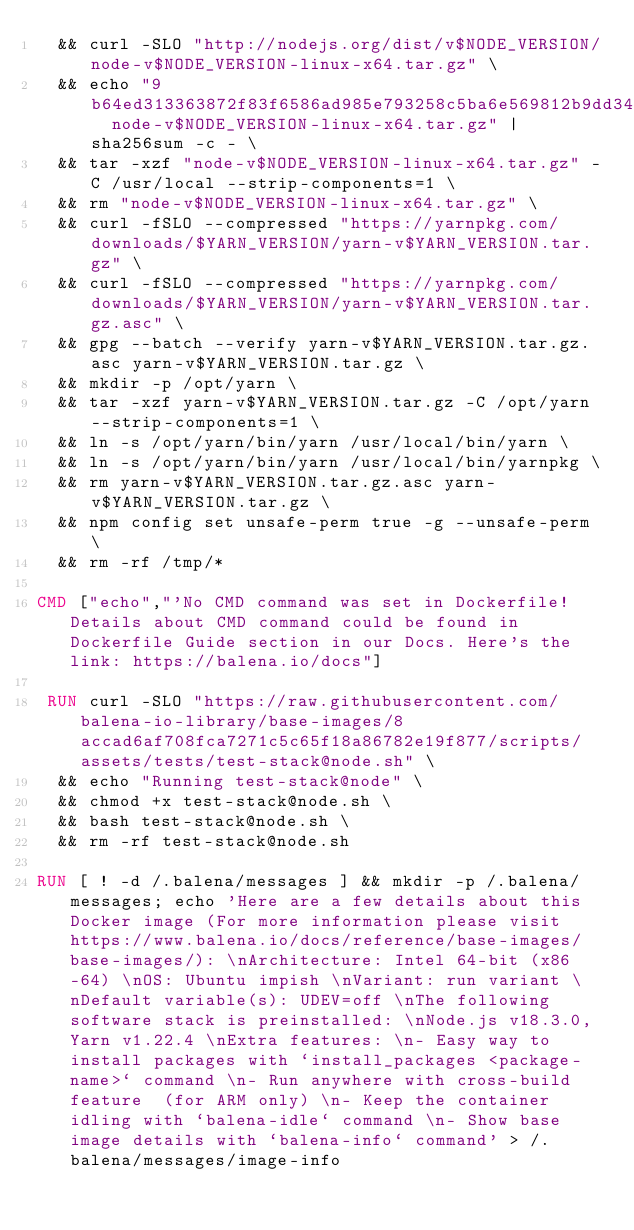<code> <loc_0><loc_0><loc_500><loc_500><_Dockerfile_>	&& curl -SLO "http://nodejs.org/dist/v$NODE_VERSION/node-v$NODE_VERSION-linux-x64.tar.gz" \
	&& echo "9b64ed313363872f83f6586ad985e793258c5ba6e569812b9dd349ec819956cf  node-v$NODE_VERSION-linux-x64.tar.gz" | sha256sum -c - \
	&& tar -xzf "node-v$NODE_VERSION-linux-x64.tar.gz" -C /usr/local --strip-components=1 \
	&& rm "node-v$NODE_VERSION-linux-x64.tar.gz" \
	&& curl -fSLO --compressed "https://yarnpkg.com/downloads/$YARN_VERSION/yarn-v$YARN_VERSION.tar.gz" \
	&& curl -fSLO --compressed "https://yarnpkg.com/downloads/$YARN_VERSION/yarn-v$YARN_VERSION.tar.gz.asc" \
	&& gpg --batch --verify yarn-v$YARN_VERSION.tar.gz.asc yarn-v$YARN_VERSION.tar.gz \
	&& mkdir -p /opt/yarn \
	&& tar -xzf yarn-v$YARN_VERSION.tar.gz -C /opt/yarn --strip-components=1 \
	&& ln -s /opt/yarn/bin/yarn /usr/local/bin/yarn \
	&& ln -s /opt/yarn/bin/yarn /usr/local/bin/yarnpkg \
	&& rm yarn-v$YARN_VERSION.tar.gz.asc yarn-v$YARN_VERSION.tar.gz \
	&& npm config set unsafe-perm true -g --unsafe-perm \
	&& rm -rf /tmp/*

CMD ["echo","'No CMD command was set in Dockerfile! Details about CMD command could be found in Dockerfile Guide section in our Docs. Here's the link: https://balena.io/docs"]

 RUN curl -SLO "https://raw.githubusercontent.com/balena-io-library/base-images/8accad6af708fca7271c5c65f18a86782e19f877/scripts/assets/tests/test-stack@node.sh" \
  && echo "Running test-stack@node" \
  && chmod +x test-stack@node.sh \
  && bash test-stack@node.sh \
  && rm -rf test-stack@node.sh 

RUN [ ! -d /.balena/messages ] && mkdir -p /.balena/messages; echo 'Here are a few details about this Docker image (For more information please visit https://www.balena.io/docs/reference/base-images/base-images/): \nArchitecture: Intel 64-bit (x86-64) \nOS: Ubuntu impish \nVariant: run variant \nDefault variable(s): UDEV=off \nThe following software stack is preinstalled: \nNode.js v18.3.0, Yarn v1.22.4 \nExtra features: \n- Easy way to install packages with `install_packages <package-name>` command \n- Run anywhere with cross-build feature  (for ARM only) \n- Keep the container idling with `balena-idle` command \n- Show base image details with `balena-info` command' > /.balena/messages/image-info</code> 